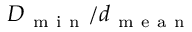Convert formula to latex. <formula><loc_0><loc_0><loc_500><loc_500>D _ { m i n } / d _ { m e a n }</formula> 